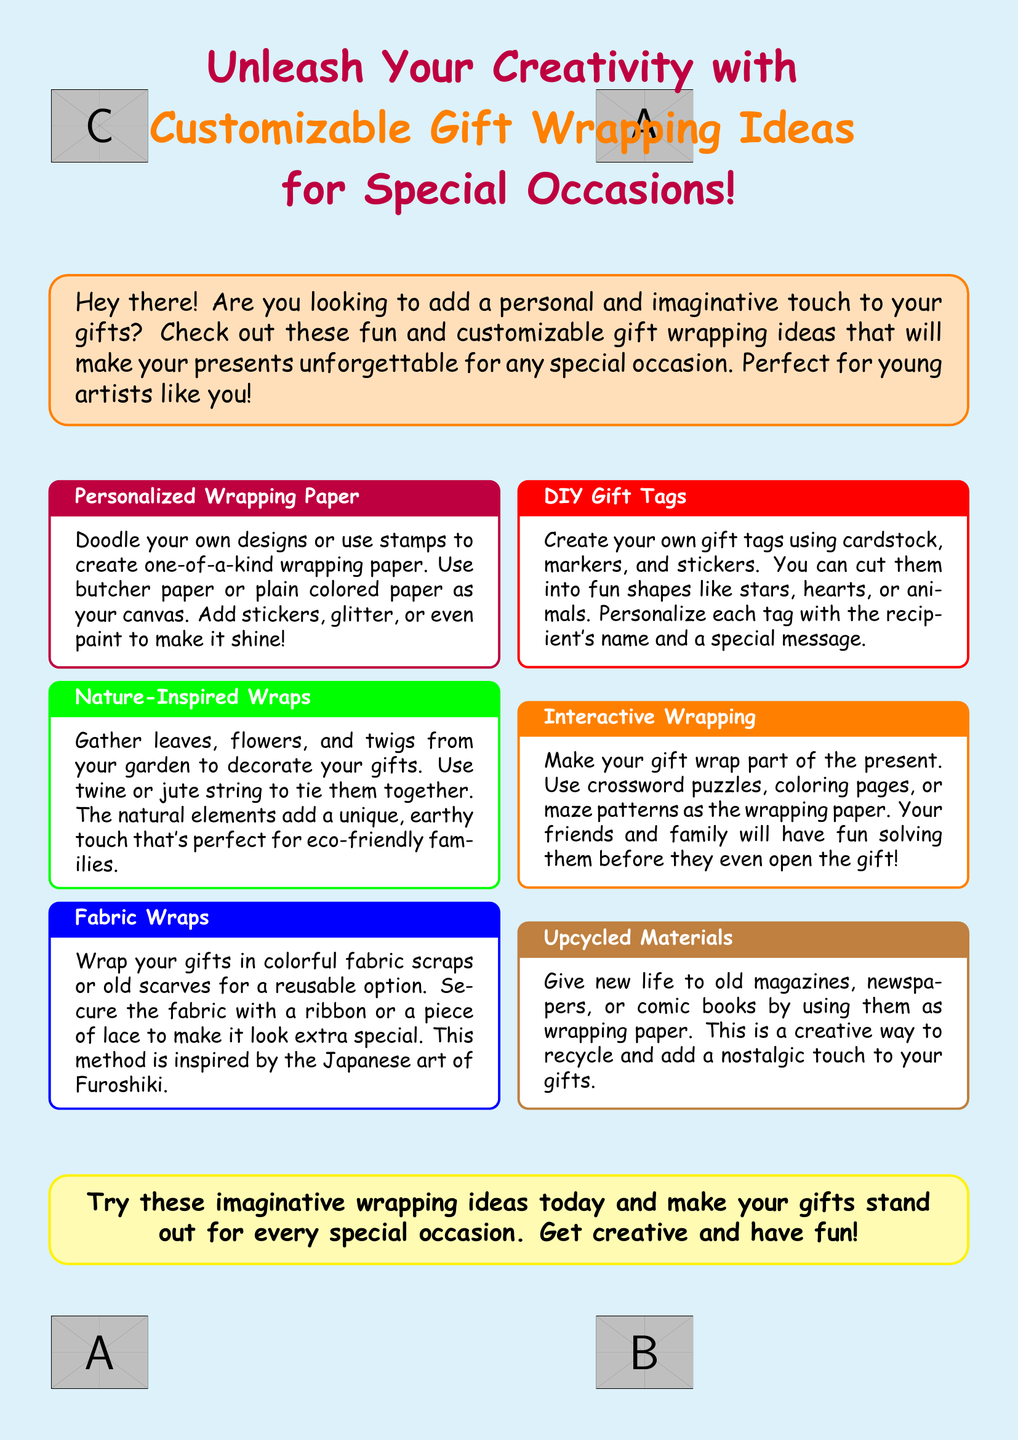What are the colors used for the wrapping ideas header? The header's colors are purple and orange.
Answer: purple and orange What is one of the wrapping ideas that uses nature elements? The wrapping idea that uses nature elements suggests gathering leaves, flowers, and twigs.
Answer: Nature-Inspired Wraps What can you use to create your own gift tags? You can create gift tags using cardstock, markers, and stickers.
Answer: cardstock, markers, and stickers What wrapping method is inspired by Japanese art? The wrapping method inspired by Japanese art is called Furoshiki.
Answer: Furoshiki What type of paper can be used to doodle your designs? You can use butcher paper or plain colored paper as your canvas.
Answer: butcher paper or plain colored paper What is one way to make wrapping interactive? One way to make wrapping interactive is to use crossword puzzles or coloring pages.
Answer: crossword puzzles or coloring pages 